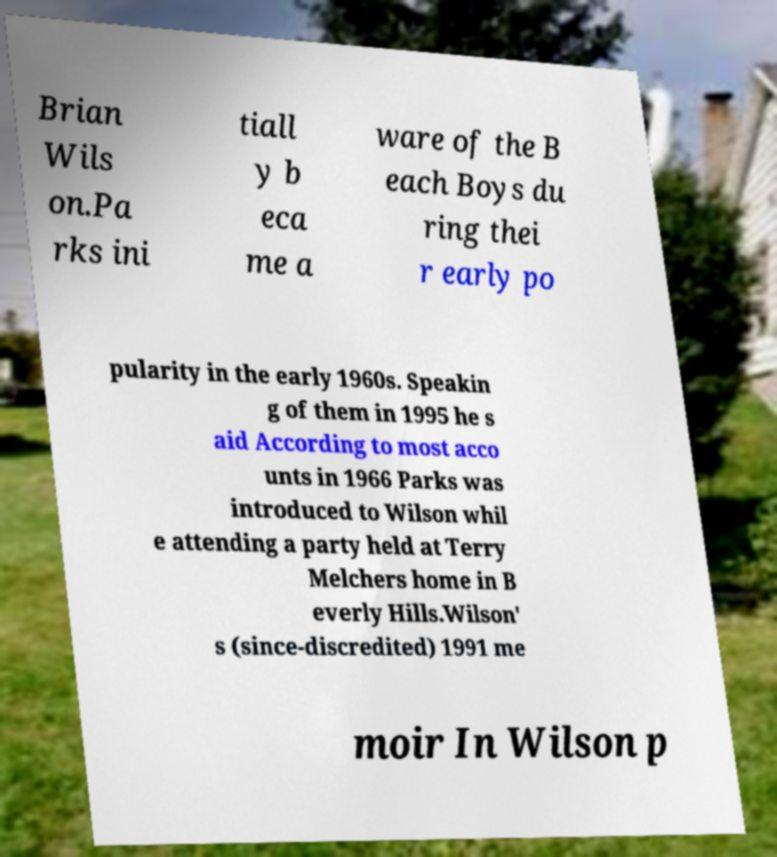Please read and relay the text visible in this image. What does it say? Brian Wils on.Pa rks ini tiall y b eca me a ware of the B each Boys du ring thei r early po pularity in the early 1960s. Speakin g of them in 1995 he s aid According to most acco unts in 1966 Parks was introduced to Wilson whil e attending a party held at Terry Melchers home in B everly Hills.Wilson' s (since-discredited) 1991 me moir In Wilson p 